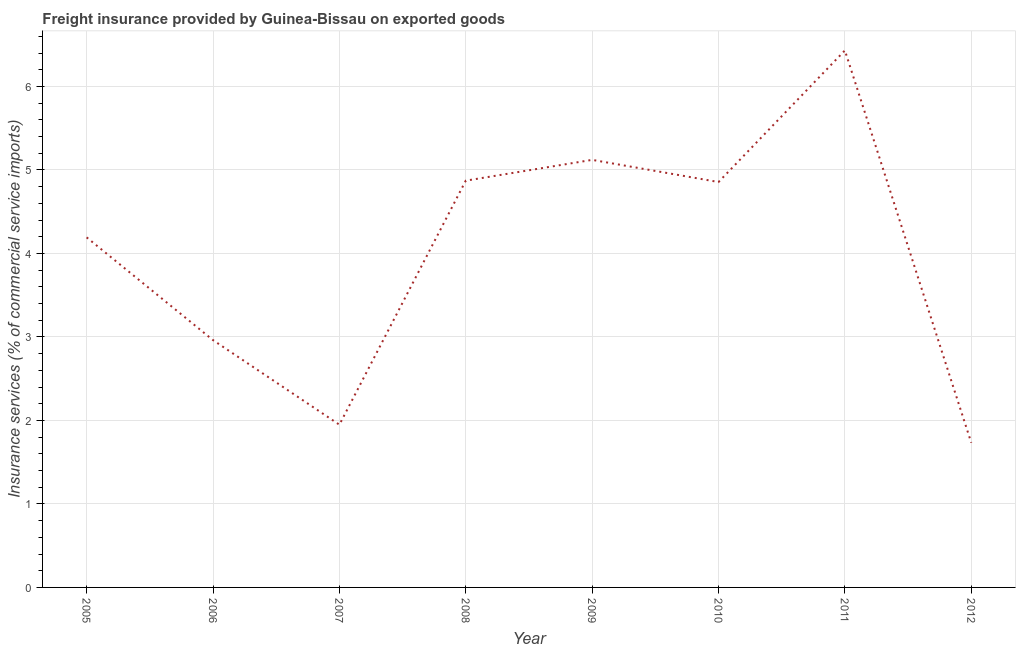What is the freight insurance in 2012?
Provide a short and direct response. 1.73. Across all years, what is the maximum freight insurance?
Offer a very short reply. 6.43. Across all years, what is the minimum freight insurance?
Offer a very short reply. 1.73. In which year was the freight insurance maximum?
Your answer should be very brief. 2011. What is the sum of the freight insurance?
Your answer should be very brief. 32.12. What is the difference between the freight insurance in 2006 and 2007?
Offer a terse response. 1.01. What is the average freight insurance per year?
Ensure brevity in your answer.  4.01. What is the median freight insurance?
Make the answer very short. 4.52. In how many years, is the freight insurance greater than 6.2 %?
Ensure brevity in your answer.  1. Do a majority of the years between 2006 and 2011 (inclusive) have freight insurance greater than 4.6 %?
Your answer should be compact. Yes. What is the ratio of the freight insurance in 2007 to that in 2009?
Give a very brief answer. 0.38. Is the difference between the freight insurance in 2005 and 2007 greater than the difference between any two years?
Keep it short and to the point. No. What is the difference between the highest and the second highest freight insurance?
Provide a succinct answer. 1.31. Is the sum of the freight insurance in 2006 and 2009 greater than the maximum freight insurance across all years?
Provide a succinct answer. Yes. What is the difference between the highest and the lowest freight insurance?
Your response must be concise. 4.7. In how many years, is the freight insurance greater than the average freight insurance taken over all years?
Your answer should be compact. 5. Are the values on the major ticks of Y-axis written in scientific E-notation?
Offer a terse response. No. What is the title of the graph?
Provide a short and direct response. Freight insurance provided by Guinea-Bissau on exported goods . What is the label or title of the X-axis?
Give a very brief answer. Year. What is the label or title of the Y-axis?
Keep it short and to the point. Insurance services (% of commercial service imports). What is the Insurance services (% of commercial service imports) in 2005?
Your answer should be very brief. 4.19. What is the Insurance services (% of commercial service imports) of 2006?
Give a very brief answer. 2.96. What is the Insurance services (% of commercial service imports) of 2007?
Keep it short and to the point. 1.95. What is the Insurance services (% of commercial service imports) in 2008?
Keep it short and to the point. 4.87. What is the Insurance services (% of commercial service imports) in 2009?
Give a very brief answer. 5.12. What is the Insurance services (% of commercial service imports) of 2010?
Provide a short and direct response. 4.86. What is the Insurance services (% of commercial service imports) of 2011?
Provide a short and direct response. 6.43. What is the Insurance services (% of commercial service imports) of 2012?
Your response must be concise. 1.73. What is the difference between the Insurance services (% of commercial service imports) in 2005 and 2006?
Offer a very short reply. 1.23. What is the difference between the Insurance services (% of commercial service imports) in 2005 and 2007?
Provide a succinct answer. 2.24. What is the difference between the Insurance services (% of commercial service imports) in 2005 and 2008?
Ensure brevity in your answer.  -0.68. What is the difference between the Insurance services (% of commercial service imports) in 2005 and 2009?
Your answer should be very brief. -0.93. What is the difference between the Insurance services (% of commercial service imports) in 2005 and 2010?
Keep it short and to the point. -0.66. What is the difference between the Insurance services (% of commercial service imports) in 2005 and 2011?
Offer a terse response. -2.24. What is the difference between the Insurance services (% of commercial service imports) in 2005 and 2012?
Your answer should be very brief. 2.46. What is the difference between the Insurance services (% of commercial service imports) in 2006 and 2007?
Your answer should be very brief. 1.01. What is the difference between the Insurance services (% of commercial service imports) in 2006 and 2008?
Your answer should be very brief. -1.91. What is the difference between the Insurance services (% of commercial service imports) in 2006 and 2009?
Offer a very short reply. -2.16. What is the difference between the Insurance services (% of commercial service imports) in 2006 and 2010?
Ensure brevity in your answer.  -1.89. What is the difference between the Insurance services (% of commercial service imports) in 2006 and 2011?
Give a very brief answer. -3.47. What is the difference between the Insurance services (% of commercial service imports) in 2006 and 2012?
Your response must be concise. 1.23. What is the difference between the Insurance services (% of commercial service imports) in 2007 and 2008?
Offer a terse response. -2.92. What is the difference between the Insurance services (% of commercial service imports) in 2007 and 2009?
Offer a terse response. -3.17. What is the difference between the Insurance services (% of commercial service imports) in 2007 and 2010?
Your answer should be compact. -2.91. What is the difference between the Insurance services (% of commercial service imports) in 2007 and 2011?
Offer a terse response. -4.48. What is the difference between the Insurance services (% of commercial service imports) in 2007 and 2012?
Ensure brevity in your answer.  0.22. What is the difference between the Insurance services (% of commercial service imports) in 2008 and 2009?
Your answer should be very brief. -0.25. What is the difference between the Insurance services (% of commercial service imports) in 2008 and 2010?
Provide a short and direct response. 0.02. What is the difference between the Insurance services (% of commercial service imports) in 2008 and 2011?
Your answer should be compact. -1.56. What is the difference between the Insurance services (% of commercial service imports) in 2008 and 2012?
Your answer should be compact. 3.14. What is the difference between the Insurance services (% of commercial service imports) in 2009 and 2010?
Ensure brevity in your answer.  0.27. What is the difference between the Insurance services (% of commercial service imports) in 2009 and 2011?
Provide a succinct answer. -1.31. What is the difference between the Insurance services (% of commercial service imports) in 2009 and 2012?
Ensure brevity in your answer.  3.39. What is the difference between the Insurance services (% of commercial service imports) in 2010 and 2011?
Your response must be concise. -1.58. What is the difference between the Insurance services (% of commercial service imports) in 2010 and 2012?
Your answer should be compact. 3.12. What is the difference between the Insurance services (% of commercial service imports) in 2011 and 2012?
Your response must be concise. 4.7. What is the ratio of the Insurance services (% of commercial service imports) in 2005 to that in 2006?
Your answer should be very brief. 1.42. What is the ratio of the Insurance services (% of commercial service imports) in 2005 to that in 2007?
Provide a succinct answer. 2.15. What is the ratio of the Insurance services (% of commercial service imports) in 2005 to that in 2008?
Provide a succinct answer. 0.86. What is the ratio of the Insurance services (% of commercial service imports) in 2005 to that in 2009?
Your answer should be very brief. 0.82. What is the ratio of the Insurance services (% of commercial service imports) in 2005 to that in 2010?
Your answer should be very brief. 0.86. What is the ratio of the Insurance services (% of commercial service imports) in 2005 to that in 2011?
Your answer should be very brief. 0.65. What is the ratio of the Insurance services (% of commercial service imports) in 2005 to that in 2012?
Offer a very short reply. 2.42. What is the ratio of the Insurance services (% of commercial service imports) in 2006 to that in 2007?
Give a very brief answer. 1.52. What is the ratio of the Insurance services (% of commercial service imports) in 2006 to that in 2008?
Provide a short and direct response. 0.61. What is the ratio of the Insurance services (% of commercial service imports) in 2006 to that in 2009?
Provide a succinct answer. 0.58. What is the ratio of the Insurance services (% of commercial service imports) in 2006 to that in 2010?
Ensure brevity in your answer.  0.61. What is the ratio of the Insurance services (% of commercial service imports) in 2006 to that in 2011?
Keep it short and to the point. 0.46. What is the ratio of the Insurance services (% of commercial service imports) in 2006 to that in 2012?
Offer a terse response. 1.71. What is the ratio of the Insurance services (% of commercial service imports) in 2007 to that in 2009?
Provide a succinct answer. 0.38. What is the ratio of the Insurance services (% of commercial service imports) in 2007 to that in 2010?
Your response must be concise. 0.4. What is the ratio of the Insurance services (% of commercial service imports) in 2007 to that in 2011?
Provide a succinct answer. 0.3. What is the ratio of the Insurance services (% of commercial service imports) in 2008 to that in 2009?
Give a very brief answer. 0.95. What is the ratio of the Insurance services (% of commercial service imports) in 2008 to that in 2011?
Offer a terse response. 0.76. What is the ratio of the Insurance services (% of commercial service imports) in 2008 to that in 2012?
Offer a very short reply. 2.81. What is the ratio of the Insurance services (% of commercial service imports) in 2009 to that in 2010?
Offer a terse response. 1.05. What is the ratio of the Insurance services (% of commercial service imports) in 2009 to that in 2011?
Give a very brief answer. 0.8. What is the ratio of the Insurance services (% of commercial service imports) in 2009 to that in 2012?
Your response must be concise. 2.96. What is the ratio of the Insurance services (% of commercial service imports) in 2010 to that in 2011?
Keep it short and to the point. 0.76. What is the ratio of the Insurance services (% of commercial service imports) in 2010 to that in 2012?
Give a very brief answer. 2.8. What is the ratio of the Insurance services (% of commercial service imports) in 2011 to that in 2012?
Keep it short and to the point. 3.71. 